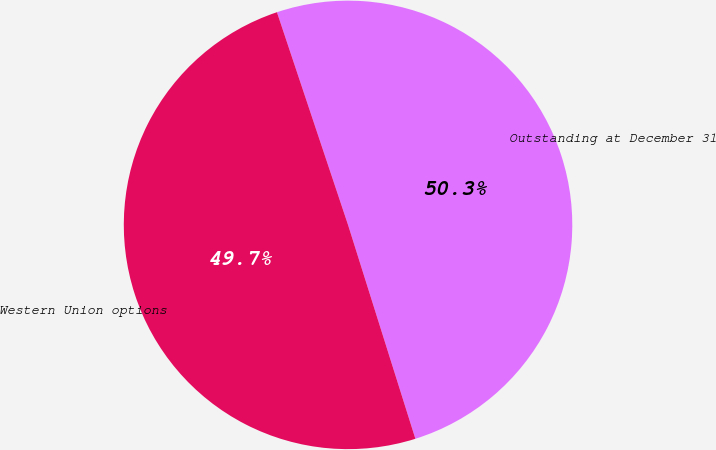Convert chart. <chart><loc_0><loc_0><loc_500><loc_500><pie_chart><fcel>Outstanding at December 31<fcel>Western Union options<nl><fcel>50.28%<fcel>49.72%<nl></chart> 